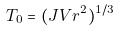Convert formula to latex. <formula><loc_0><loc_0><loc_500><loc_500>T _ { 0 } = ( J V r ^ { 2 } ) ^ { 1 / 3 }</formula> 